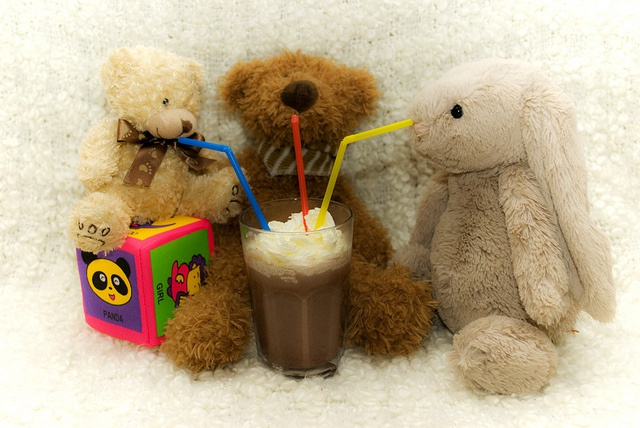Describe the objects in this image and their specific colors. I can see teddy bear in ivory, tan, and gray tones, teddy bear in ivory, maroon, olive, and black tones, teddy bear in ivory, tan, and olive tones, and cup in ivory, maroon, black, and khaki tones in this image. 